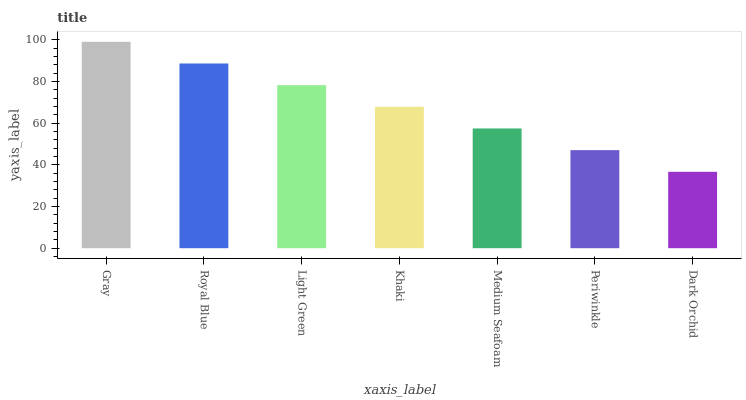Is Dark Orchid the minimum?
Answer yes or no. Yes. Is Gray the maximum?
Answer yes or no. Yes. Is Royal Blue the minimum?
Answer yes or no. No. Is Royal Blue the maximum?
Answer yes or no. No. Is Gray greater than Royal Blue?
Answer yes or no. Yes. Is Royal Blue less than Gray?
Answer yes or no. Yes. Is Royal Blue greater than Gray?
Answer yes or no. No. Is Gray less than Royal Blue?
Answer yes or no. No. Is Khaki the high median?
Answer yes or no. Yes. Is Khaki the low median?
Answer yes or no. Yes. Is Periwinkle the high median?
Answer yes or no. No. Is Medium Seafoam the low median?
Answer yes or no. No. 